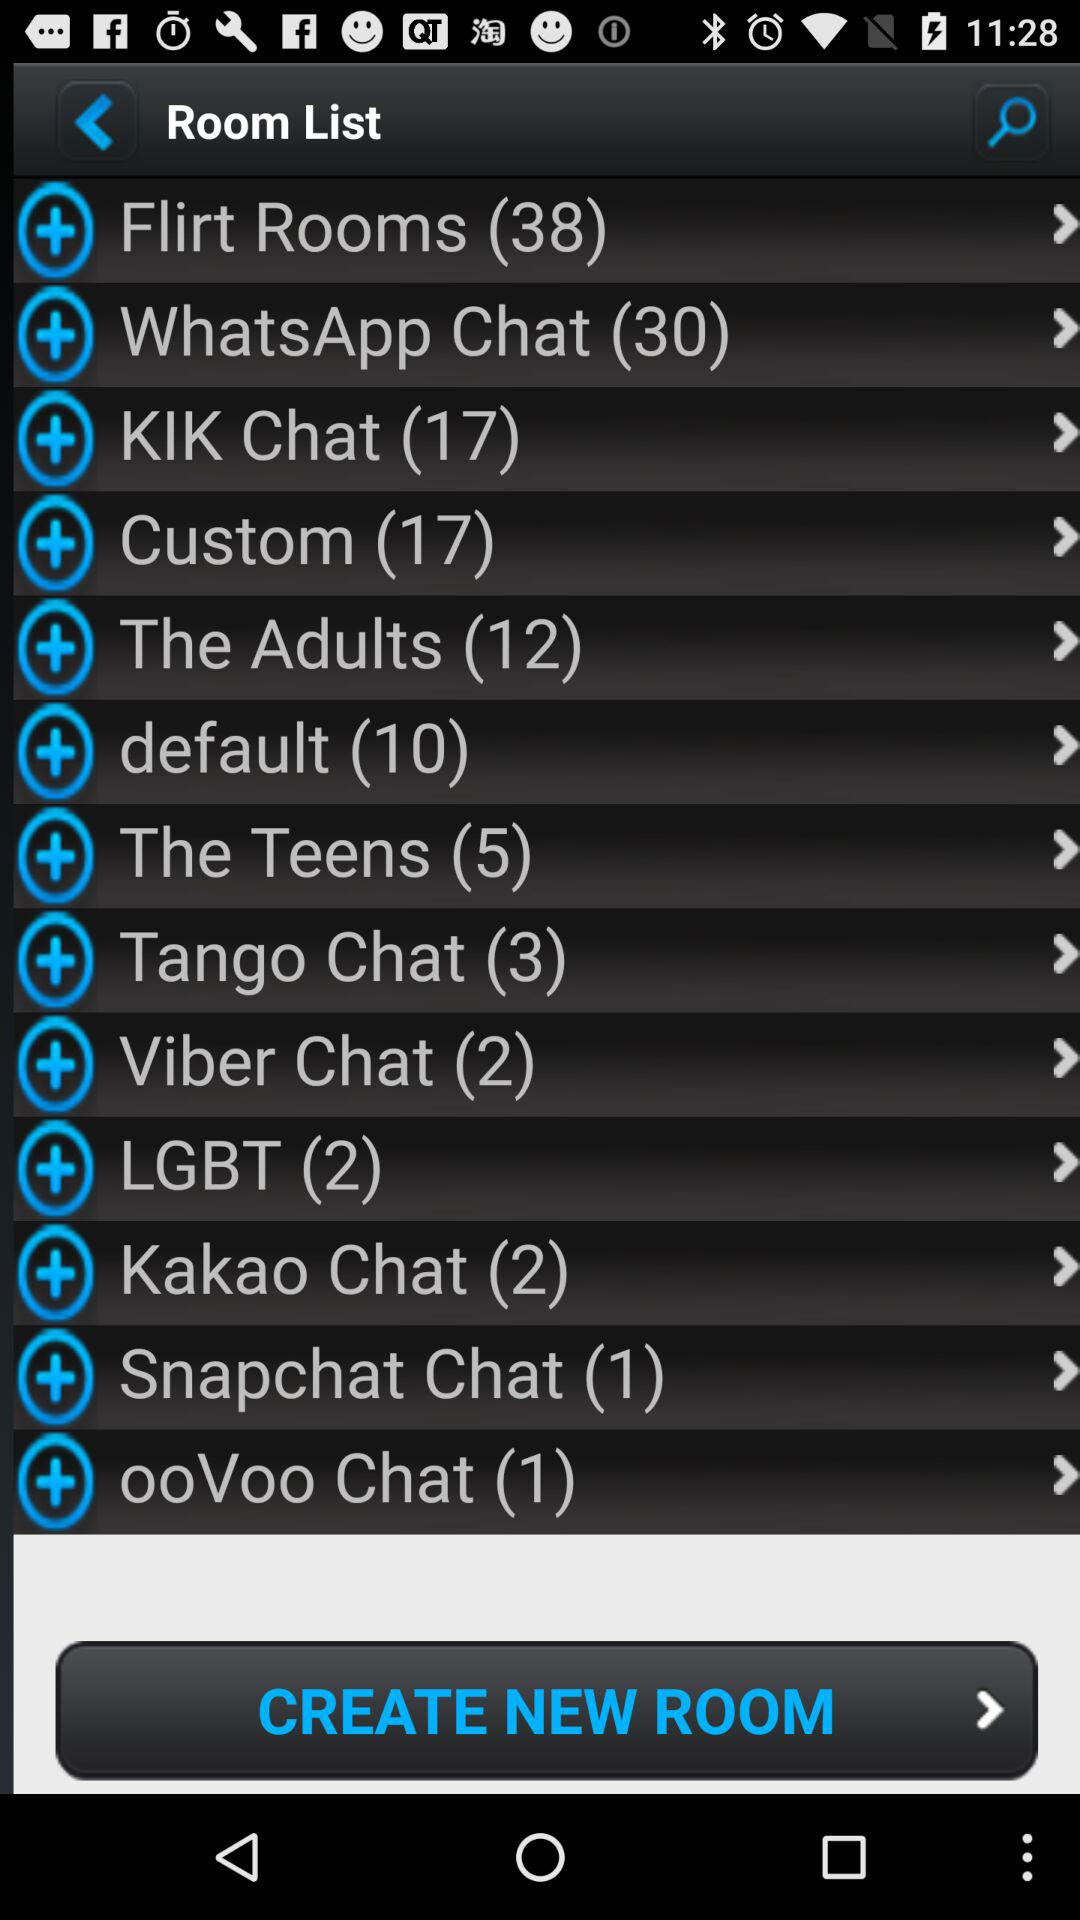What is the number in the "WhatsApp Chat"? The number in the WhatsApp chat is 30. 